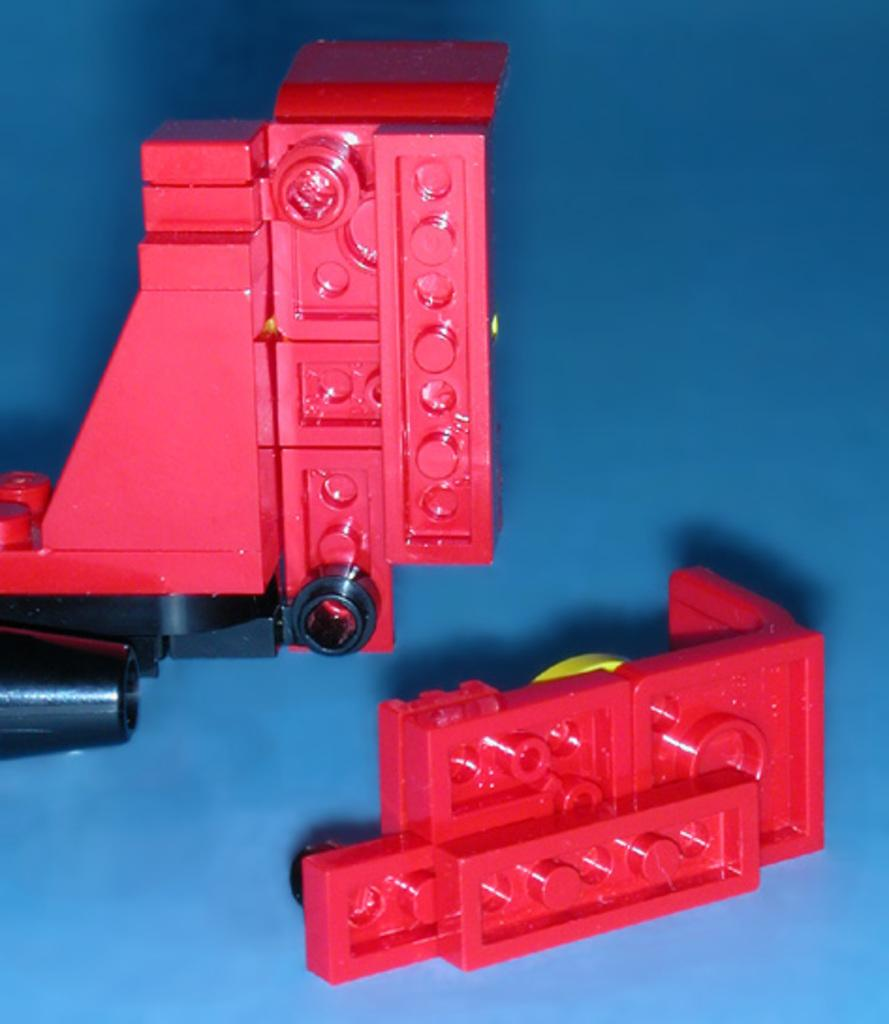What objects are present in the image? There are blocks in the image. Where are the blocks located? The blocks are kept on a table. What type of doctor is attending to the blocks in the image? There is no doctor present in the image, as it only features blocks on a table. 